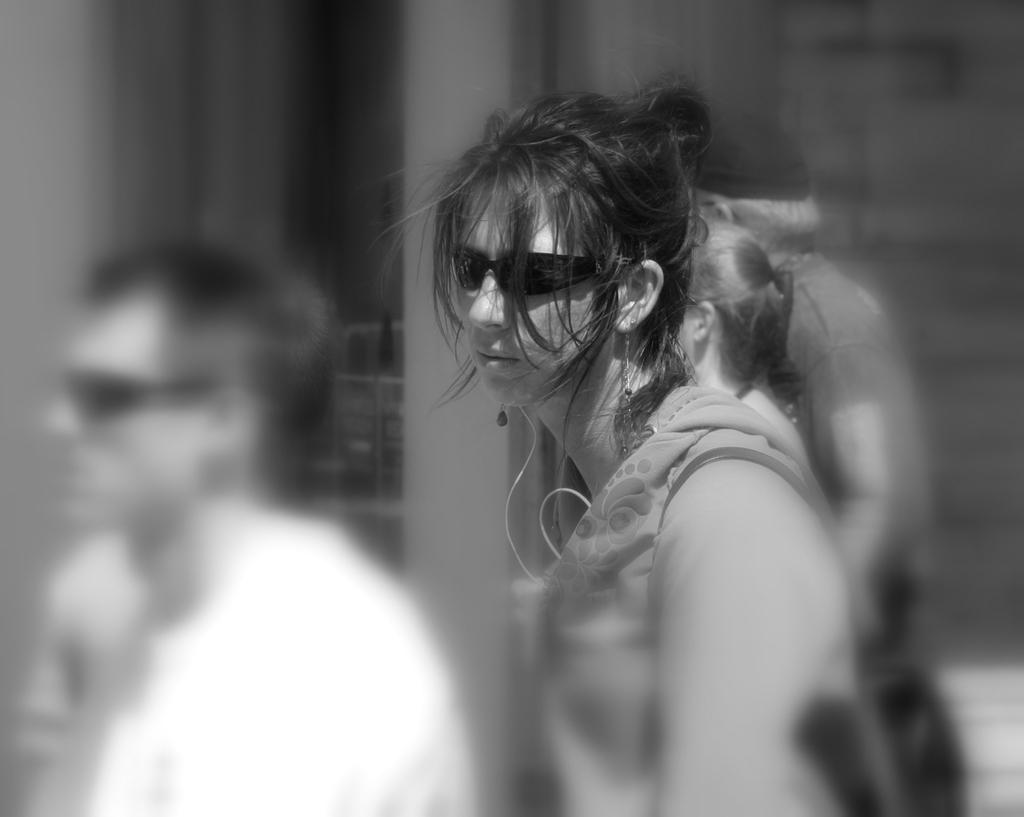How many people are in the image? There are people in the image, but the exact number is not specified. What is the lady in the center of the image doing? The lady is standing in the center of the image. What accessory is the lady wearing? The lady is wearing glasses. What can be seen in the background of the image? There is a wall and a window in the background of the image. What type of wristwatch is the lady wearing in the image? The lady is not wearing a wristwatch in the image; she is wearing glasses. What industry is depicted in the background of the image? There is no industry depicted in the image; it only shows a wall and a window in the background. 